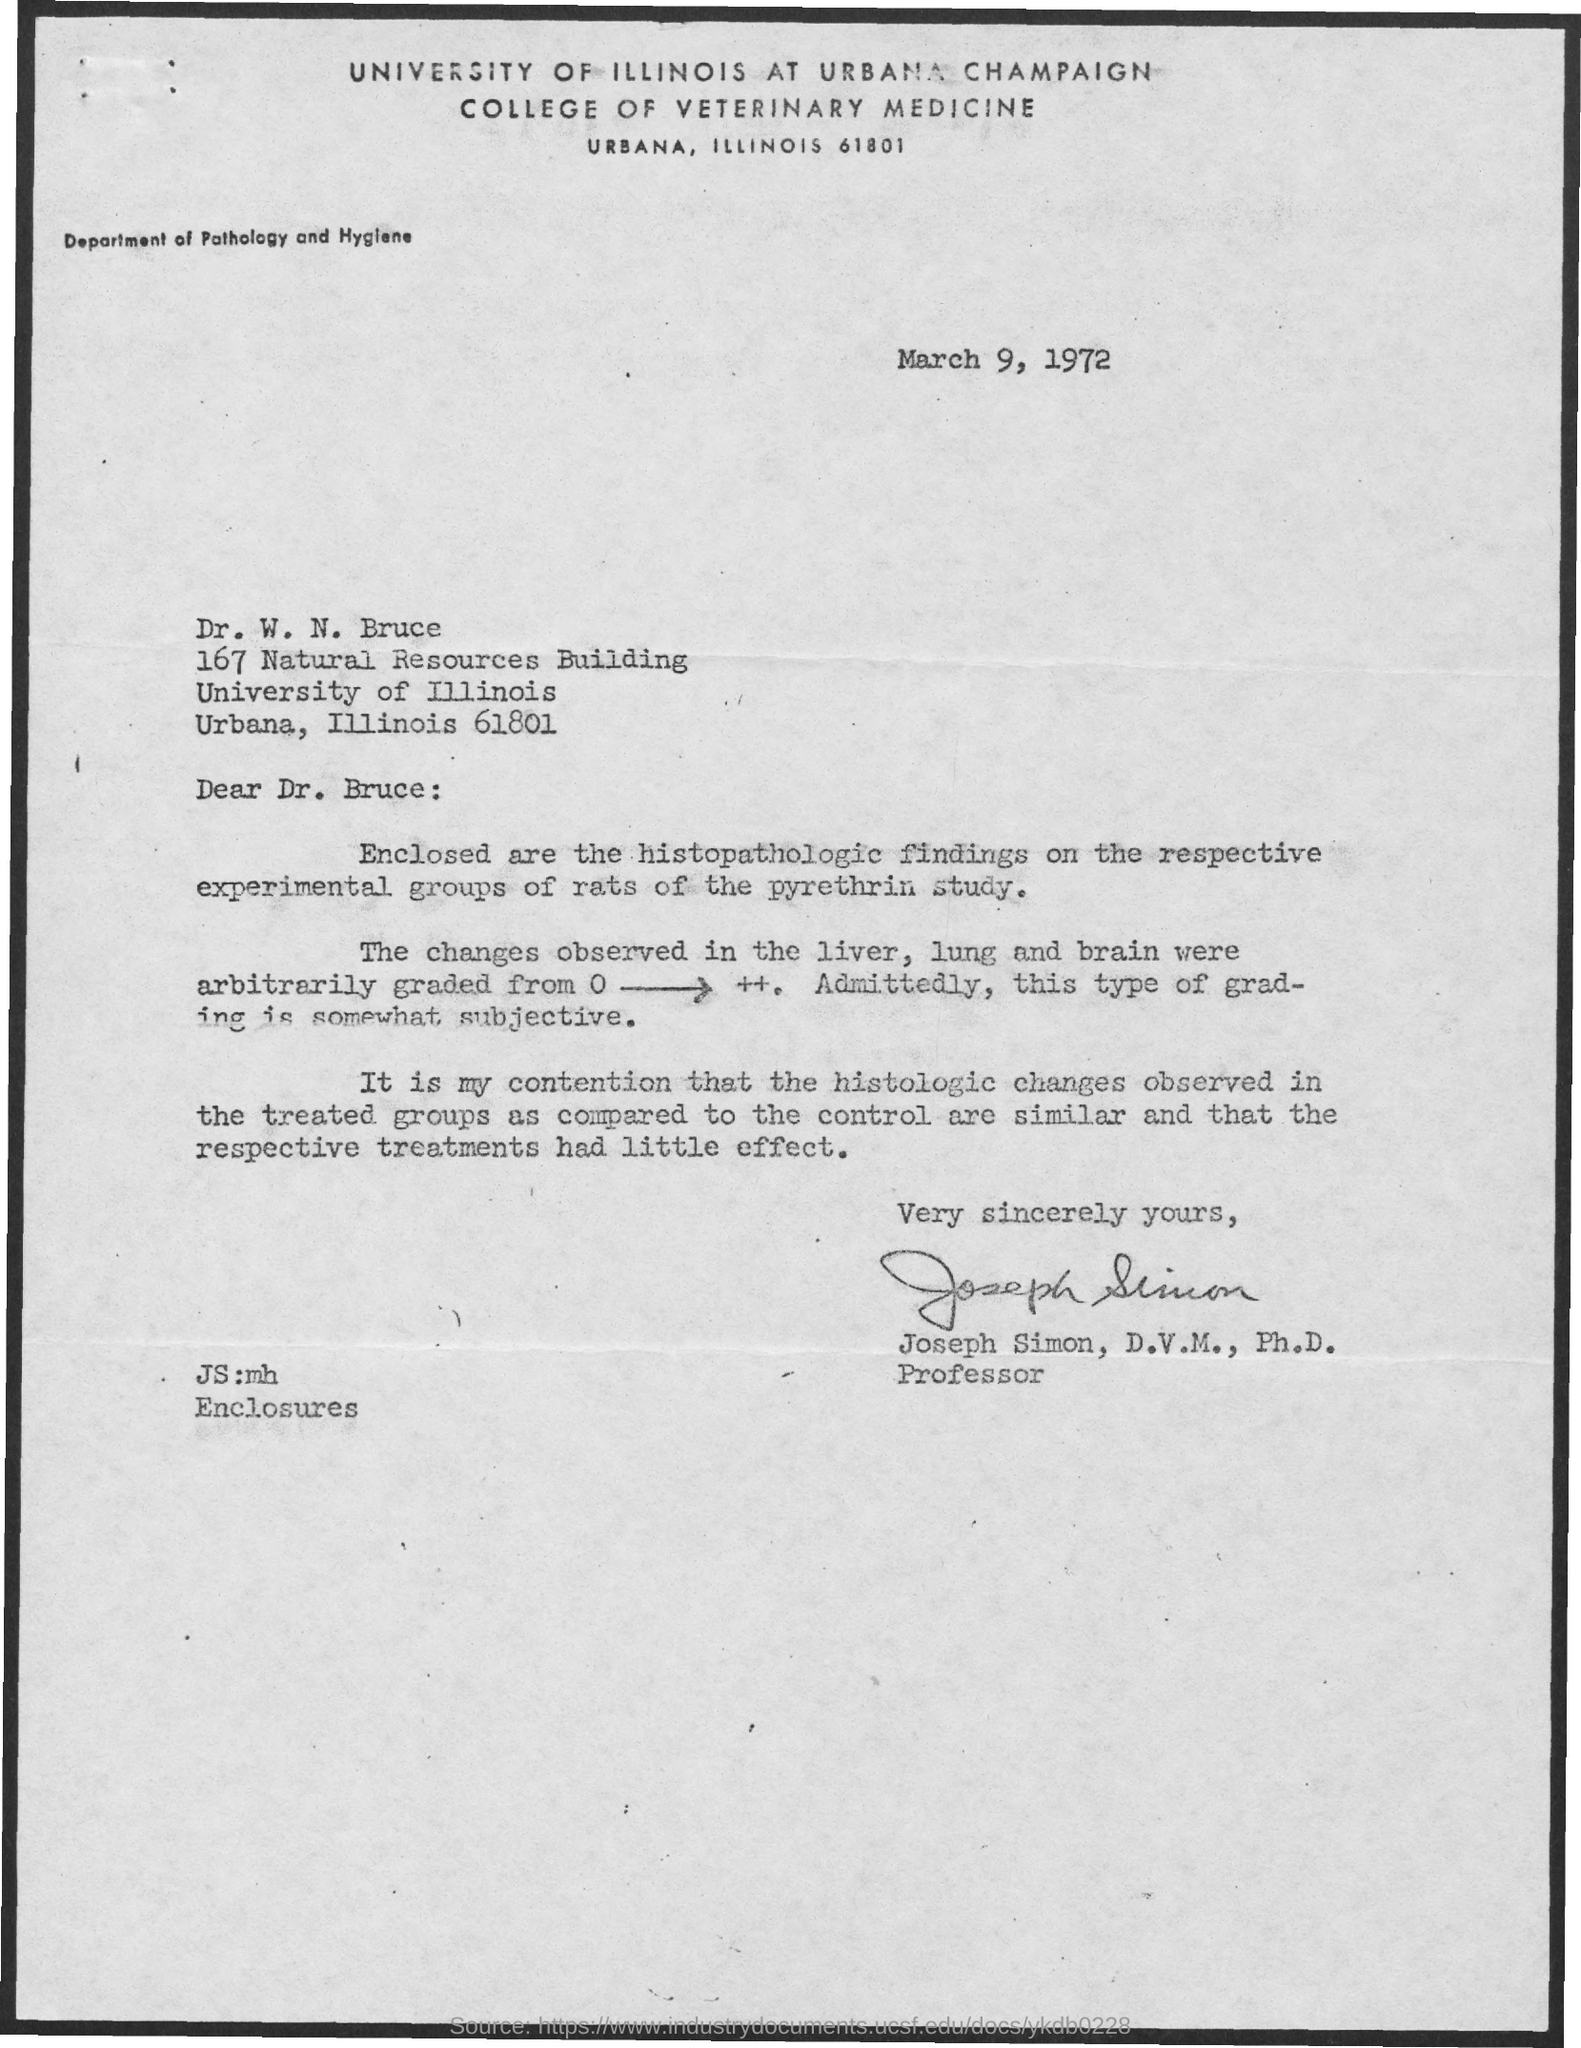Who has sent this report?
Your answer should be compact. Joseph Simon, D.V.M., Ph.D. Where is the University located?
Give a very brief answer. Urbana, Illinois. Who is this letter sent to?
Provide a short and direct response. Dr. W. N. Bruce. What are the enclosures?
Provide a short and direct response. Histopathologic findings on the respective experimental groups of rats of the pyrethrin study. Where are the changes observed?
Your answer should be very brief. Liver, Lung and Brain. Which laboratory animal is used for the study?
Your response must be concise. Rats. What is the  chemical used in the study?
Ensure brevity in your answer.  Pyrethrin. 